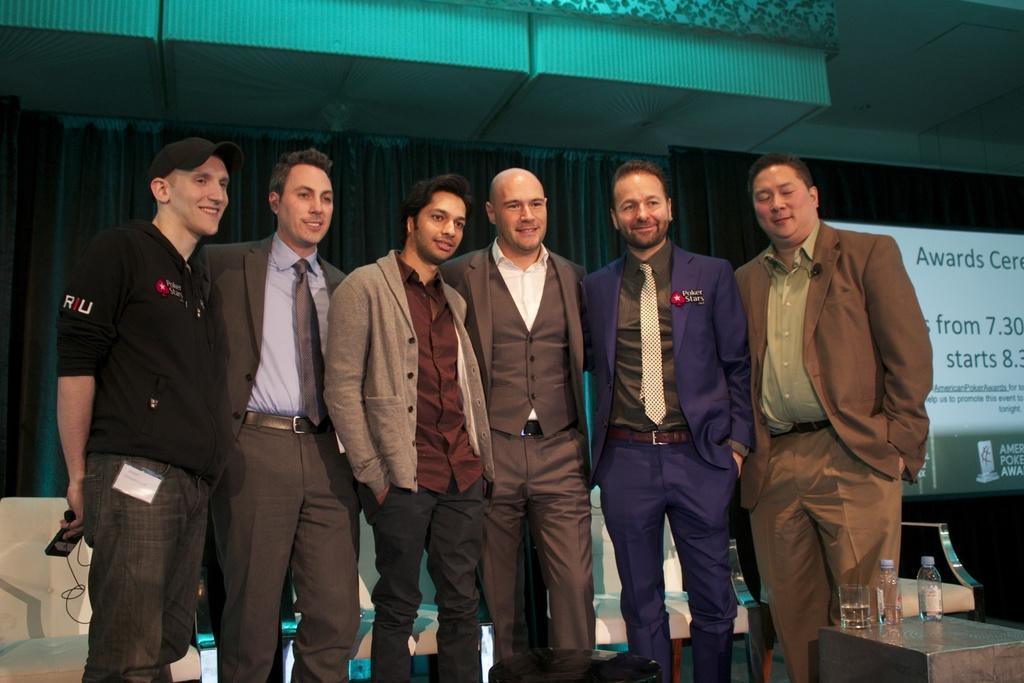Describe this image in one or two sentences. In this picture in the front is there is an empty stool, there is a table and on the table, there is a glass and there are bottles. In the center there are persons standing and smiling. In the background there are empty sofas and there is a screen with some text displaying on it and there is a curtain which is black colour. On the top there are objects which are visible. 